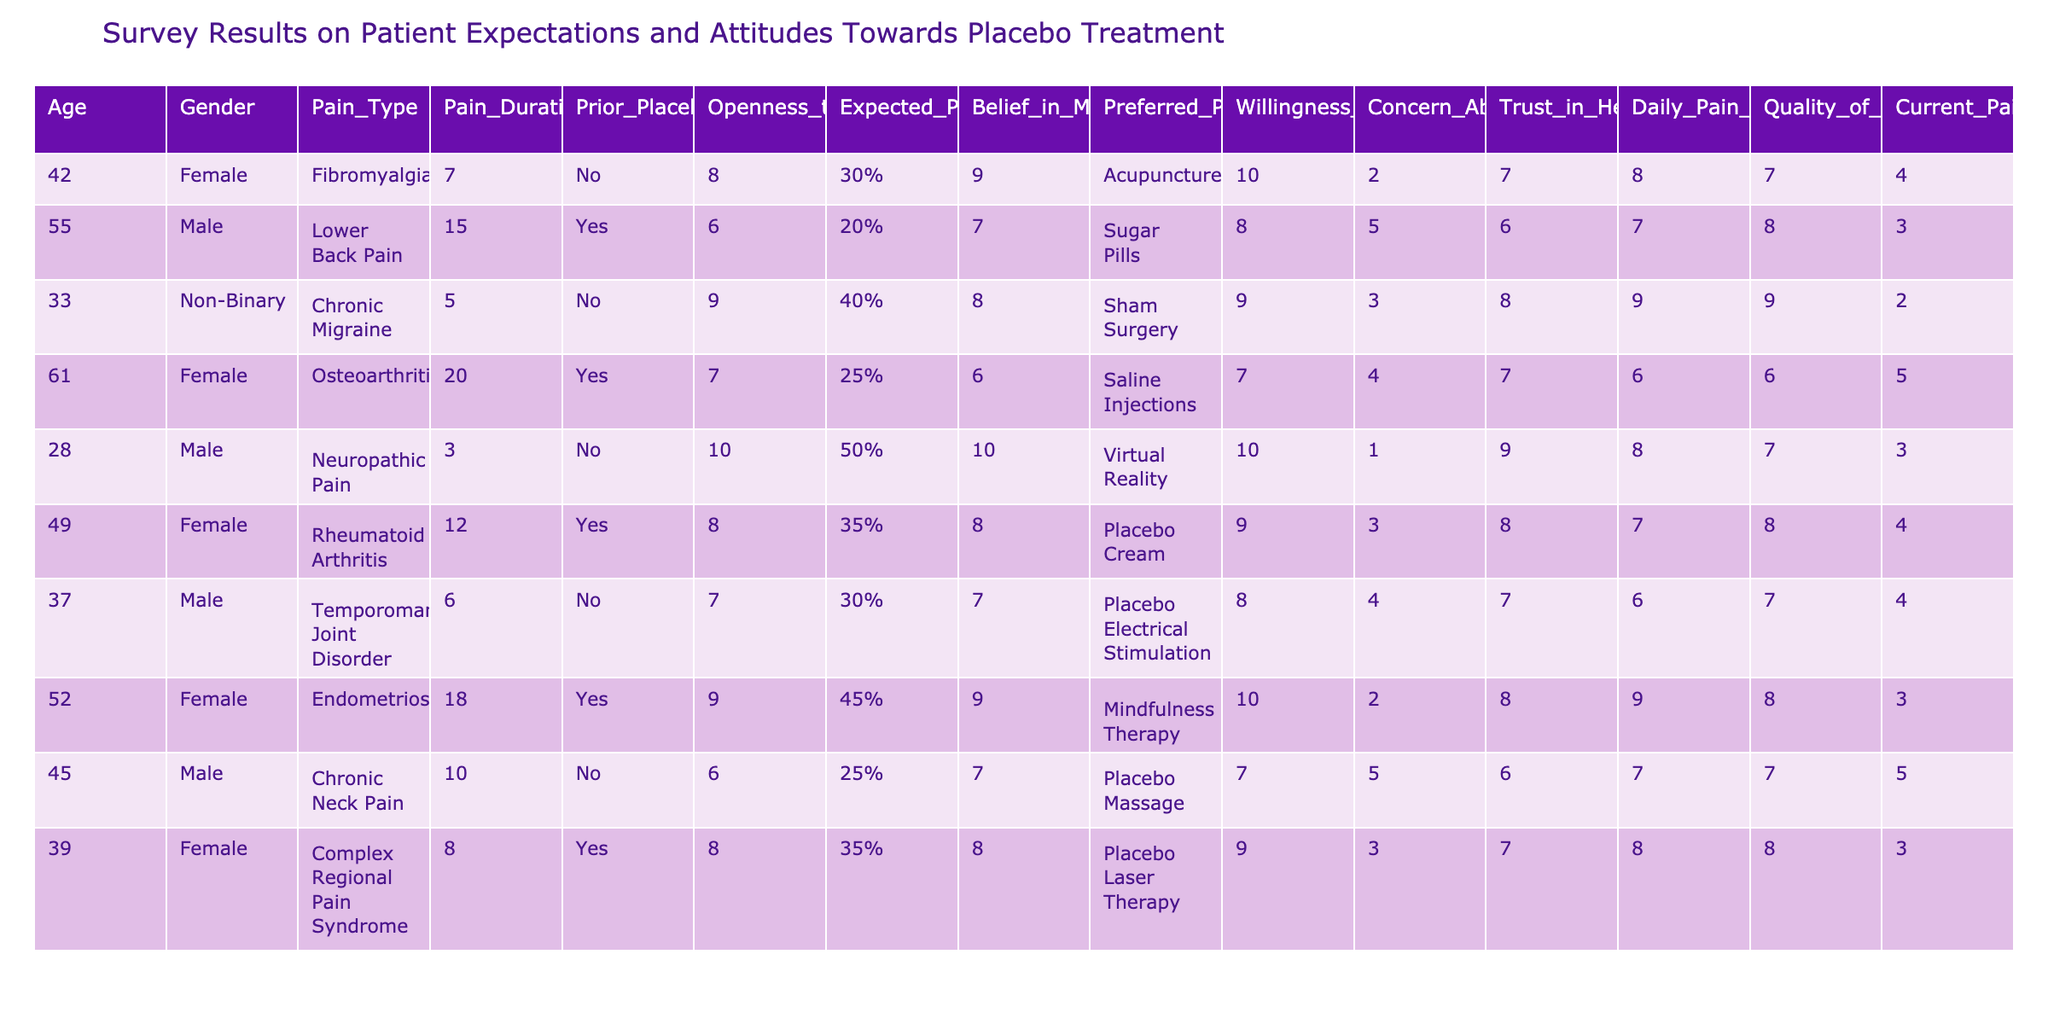What is the average age of participants in the survey? To find the average age, sum the ages of all participants (42 + 55 + 33 + 61 + 28 + 49 + 37 + 52 + 45 + 39 =  439) and divide by the number of participants (10). Thus, the average age is 439 / 10 = 43.9.
Answer: 43.9 How many participants had prior experience with placebo treatments? The data indicates prior placebo experiences for participants with lower back pain, osteoarthritis, rheumatoid arthritis, and endometriosis, totaling 4 participants.
Answer: 4 What is the highest expected pain reduction percentage reported among participants? The expected pain reduction percentages are listed as 30%, 20%, 40%, 25%, 50%, 35%, 30%, 45%, 25%, and 35%. The maximum value among these is 50%.
Answer: 50% Is there any participant who has a daily pain level greater than 8? Yes, the daily pain levels for lower back pain (8), endometriosis (9), and chronic migraine (9) are all greater than 8, confirming the statement to be true.
Answer: Yes What is the median pain duration of the participants? To find the median, first, sort the pain durations: 3, 6, 7, 8, 10, 12, 15, 18, 20. With 10 entries, the median is the average of the 5th and 6th values (10 and 12), which is (10 + 12) / 2 = 11.
Answer: 11 How many participants reported a quality of life impact of 4 or less? The quality of life impacts in the dataset are 4, 3, 2, 5, 4, 3, 3, 5, and 4. Thus, the counts of values 4 or less are 7: 4, 3, 2, 3, 3, 4, 3.
Answer: 7 In terms of preferred placebo methods, which method was preferred by the most participants? The preferred placebo methods listed are: acupuncture (1), sugar pills (1), sham surgery (1), saline injections (1), virtual reality (1), placebo cream (1), placebo electrical stimulation (1), mindfulness therapy (1), placebo massage (1), and placebo laser therapy (1). All methods have equal preference among participants, each chosen by one participant.
Answer: All methods are equally preferred What percentage of participants believe in a mind-body connection when it comes to pain management? In the dataset, the beliefs in mind-body connection scores include 9, 7, 8, 6, 10, 8, 7, 9, 8. To assess the percentage, tally those scoring 8 or higher: 6 out of 10, thus (6 / 10) * 100% = 60%.
Answer: 60% Is there a correlation between trust in healthcare providers and willingness to participate in placebo treatment? Given the trust levels (7, 6, 8, 7, 9, 8, 7, 8, 6) and willingness scores (10, 8, 9, 7, 10, 9, 8, 10, 7), evidential patterns in willingness seem to correlate positively with higher trust levels. A precise correlation requires further statistical analysis, but a general observation can be made.
Answer: Yes, a positive correlation is suggested What was the most common concern about side effects among participants? Most participants reported either 2 (2 participants), 3 (3 participants), 4 (2 participants), and 5 (2 participants) concerns about side effects. Hence, '3' concerns were the mode.
Answer: 3 concerns were most common 